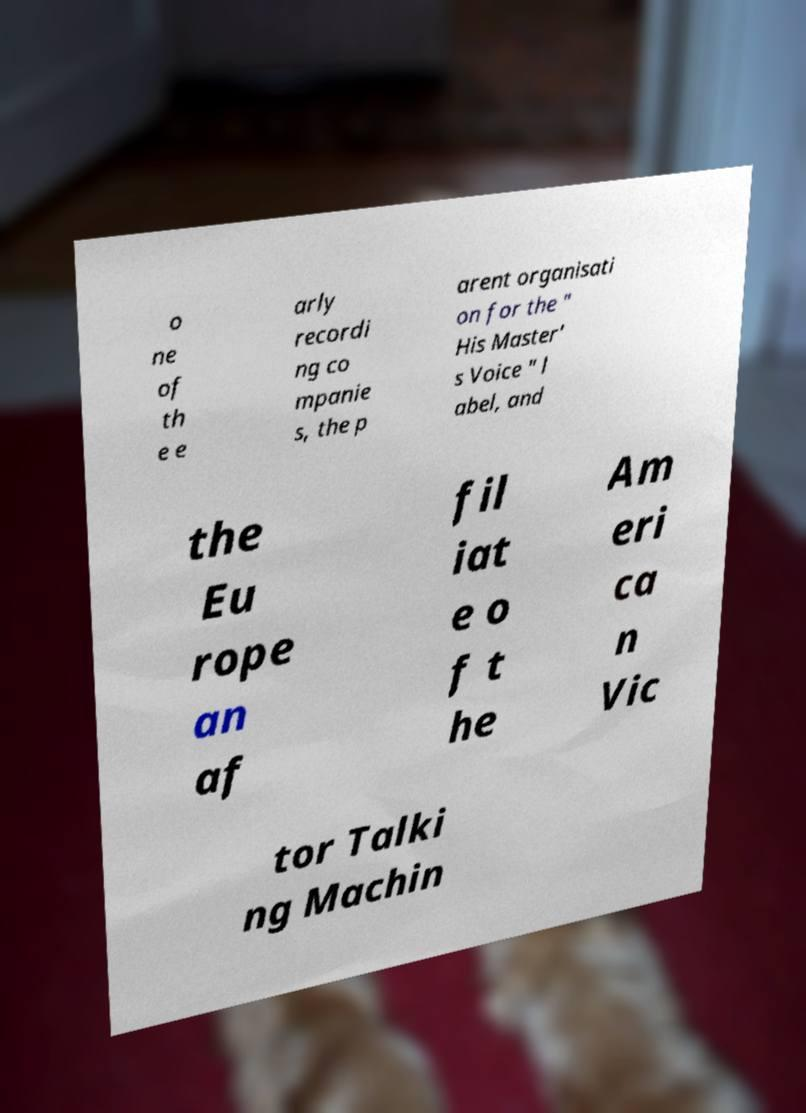Please read and relay the text visible in this image. What does it say? o ne of th e e arly recordi ng co mpanie s, the p arent organisati on for the " His Master' s Voice " l abel, and the Eu rope an af fil iat e o f t he Am eri ca n Vic tor Talki ng Machin 